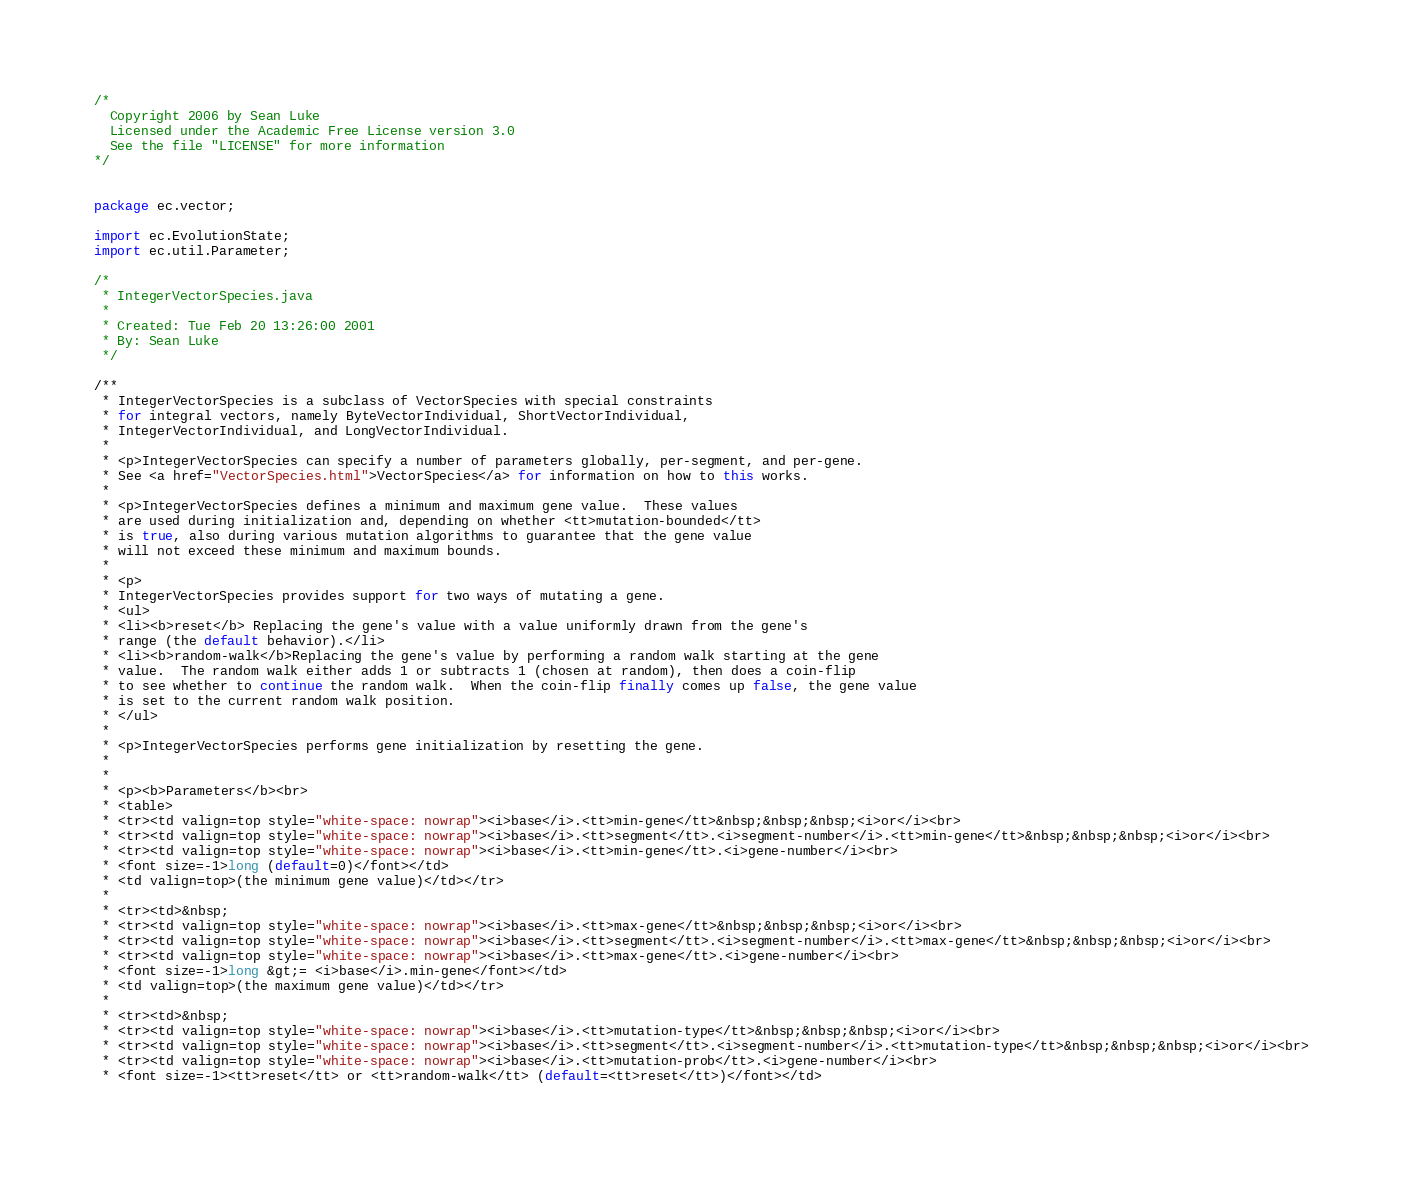Convert code to text. <code><loc_0><loc_0><loc_500><loc_500><_Java_>/*
  Copyright 2006 by Sean Luke
  Licensed under the Academic Free License version 3.0
  See the file "LICENSE" for more information
*/


package ec.vector;

import ec.EvolutionState;
import ec.util.Parameter;

/*
 * IntegerVectorSpecies.java
 *
 * Created: Tue Feb 20 13:26:00 2001
 * By: Sean Luke
 */

/**
 * IntegerVectorSpecies is a subclass of VectorSpecies with special constraints
 * for integral vectors, namely ByteVectorIndividual, ShortVectorIndividual,
 * IntegerVectorIndividual, and LongVectorIndividual.
 *
 * <p>IntegerVectorSpecies can specify a number of parameters globally, per-segment, and per-gene.
 * See <a href="VectorSpecies.html">VectorSpecies</a> for information on how to this works.
 *
 * <p>IntegerVectorSpecies defines a minimum and maximum gene value.  These values
 * are used during initialization and, depending on whether <tt>mutation-bounded</tt>
 * is true, also during various mutation algorithms to guarantee that the gene value
 * will not exceed these minimum and maximum bounds.
 *
 * <p>
 * IntegerVectorSpecies provides support for two ways of mutating a gene.
 * <ul>
 * <li><b>reset</b> Replacing the gene's value with a value uniformly drawn from the gene's
 * range (the default behavior).</li>
 * <li><b>random-walk</b>Replacing the gene's value by performing a random walk starting at the gene
 * value.  The random walk either adds 1 or subtracts 1 (chosen at random), then does a coin-flip
 * to see whether to continue the random walk.  When the coin-flip finally comes up false, the gene value
 * is set to the current random walk position.
 * </ul>
 *
 * <p>IntegerVectorSpecies performs gene initialization by resetting the gene.
 *
 *
 * <p><b>Parameters</b><br>
 * <table>
 * <tr><td valign=top style="white-space: nowrap"><i>base</i>.<tt>min-gene</tt>&nbsp;&nbsp;&nbsp;<i>or</i><br>
 * <tr><td valign=top style="white-space: nowrap"><i>base</i>.<tt>segment</tt>.<i>segment-number</i>.<tt>min-gene</tt>&nbsp;&nbsp;&nbsp;<i>or</i><br>
 * <tr><td valign=top style="white-space: nowrap"><i>base</i>.<tt>min-gene</tt>.<i>gene-number</i><br>
 * <font size=-1>long (default=0)</font></td>
 * <td valign=top>(the minimum gene value)</td></tr>
 *
 * <tr><td>&nbsp;
 * <tr><td valign=top style="white-space: nowrap"><i>base</i>.<tt>max-gene</tt>&nbsp;&nbsp;&nbsp;<i>or</i><br>
 * <tr><td valign=top style="white-space: nowrap"><i>base</i>.<tt>segment</tt>.<i>segment-number</i>.<tt>max-gene</tt>&nbsp;&nbsp;&nbsp;<i>or</i><br>
 * <tr><td valign=top style="white-space: nowrap"><i>base</i>.<tt>max-gene</tt>.<i>gene-number</i><br>
 * <font size=-1>long &gt;= <i>base</i>.min-gene</font></td>
 * <td valign=top>(the maximum gene value)</td></tr>
 *
 * <tr><td>&nbsp;
 * <tr><td valign=top style="white-space: nowrap"><i>base</i>.<tt>mutation-type</tt>&nbsp;&nbsp;&nbsp;<i>or</i><br>
 * <tr><td valign=top style="white-space: nowrap"><i>base</i>.<tt>segment</tt>.<i>segment-number</i>.<tt>mutation-type</tt>&nbsp;&nbsp;&nbsp;<i>or</i><br>
 * <tr><td valign=top style="white-space: nowrap"><i>base</i>.<tt>mutation-prob</tt>.<i>gene-number</i><br>
 * <font size=-1><tt>reset</tt> or <tt>random-walk</tt> (default=<tt>reset</tt>)</font></td></code> 